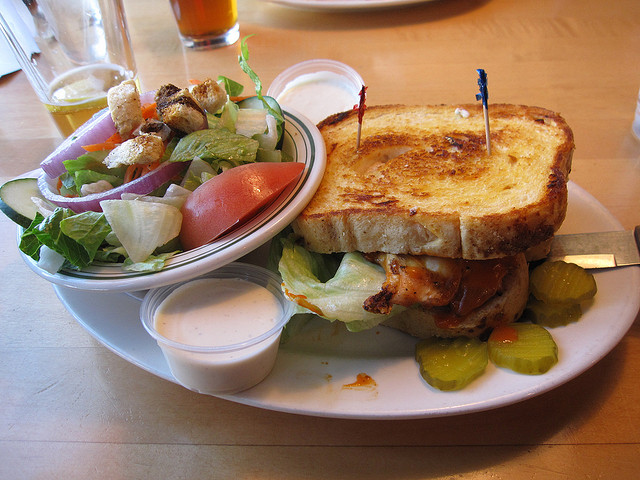What kind of salad is that to the side? The side salad features fresh greens, likely romaine and iceberg lettuce, topped with slices of tomato, cucumbers, and red onions, sprinkled with croutons with a side of what appears to be a ranch dressing. What do the croutons add to the salad? Croutons add a delightful crunch and texture to the salad, offering a contrast to the crisp vegetables and creamy dressing. They also contribute a buttery, garlic flavor that complements the salad's fresh ingredients. 